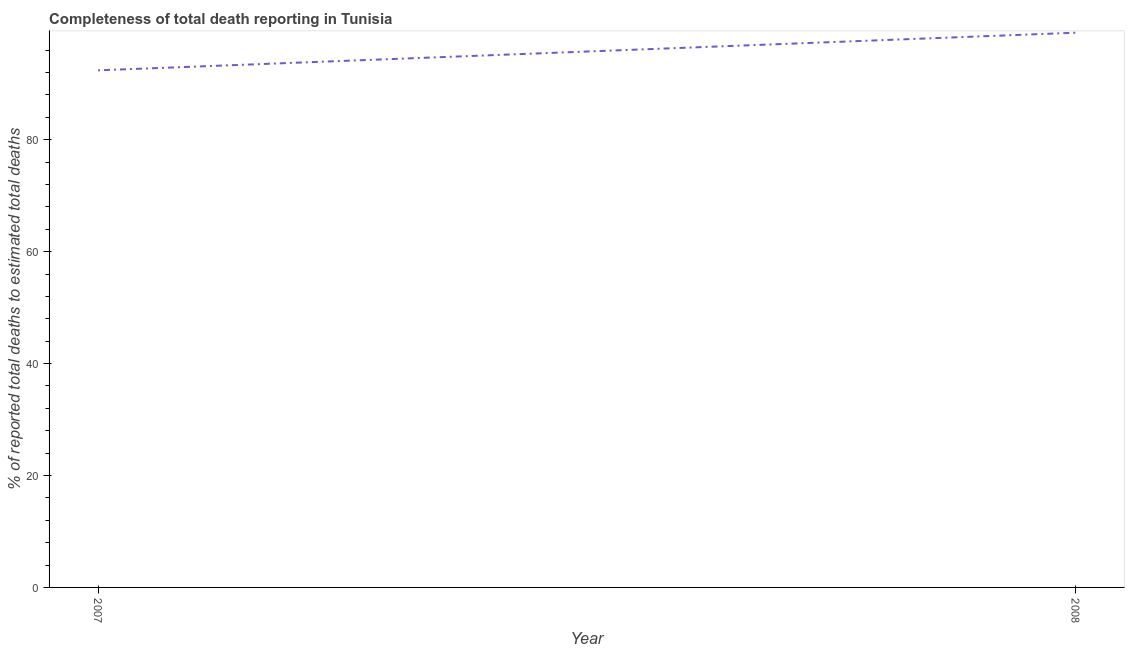What is the completeness of total death reports in 2007?
Your answer should be very brief. 92.4. Across all years, what is the maximum completeness of total death reports?
Offer a terse response. 99.13. Across all years, what is the minimum completeness of total death reports?
Ensure brevity in your answer.  92.4. In which year was the completeness of total death reports minimum?
Make the answer very short. 2007. What is the sum of the completeness of total death reports?
Ensure brevity in your answer.  191.54. What is the difference between the completeness of total death reports in 2007 and 2008?
Offer a very short reply. -6.73. What is the average completeness of total death reports per year?
Offer a very short reply. 95.77. What is the median completeness of total death reports?
Offer a terse response. 95.77. What is the ratio of the completeness of total death reports in 2007 to that in 2008?
Provide a short and direct response. 0.93. In how many years, is the completeness of total death reports greater than the average completeness of total death reports taken over all years?
Make the answer very short. 1. Does the completeness of total death reports monotonically increase over the years?
Ensure brevity in your answer.  Yes. How many lines are there?
Offer a very short reply. 1. How many years are there in the graph?
Your answer should be compact. 2. Are the values on the major ticks of Y-axis written in scientific E-notation?
Give a very brief answer. No. What is the title of the graph?
Your answer should be very brief. Completeness of total death reporting in Tunisia. What is the label or title of the Y-axis?
Give a very brief answer. % of reported total deaths to estimated total deaths. What is the % of reported total deaths to estimated total deaths in 2007?
Your response must be concise. 92.4. What is the % of reported total deaths to estimated total deaths of 2008?
Keep it short and to the point. 99.13. What is the difference between the % of reported total deaths to estimated total deaths in 2007 and 2008?
Your answer should be compact. -6.73. What is the ratio of the % of reported total deaths to estimated total deaths in 2007 to that in 2008?
Your answer should be very brief. 0.93. 